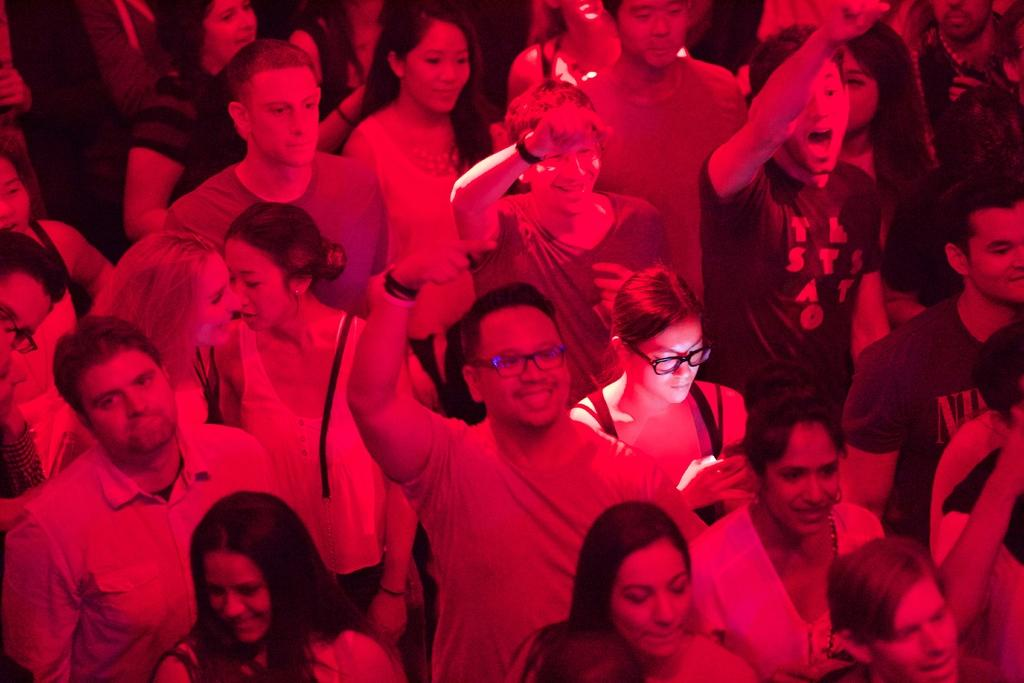What is the main subject of the image? The main subject of the image is a group of people. What are the people in the image doing? The people are standing in the image. What is the emotional expression of the people in the image? The people are smiling in the image. What type of corn can be seen growing in the image? There is no corn present in the image; it features a group of people standing and smiling. How tall are the giants in the image? There are no giants present in the image; it features a group of people standing and smiling. 